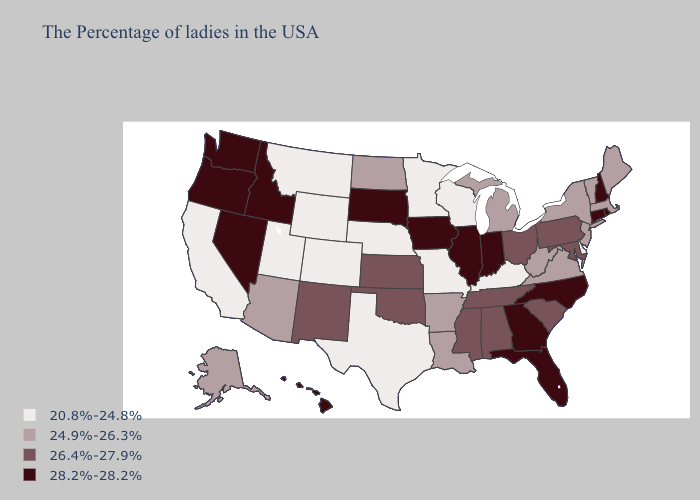What is the value of Georgia?
Write a very short answer. 28.2%-28.2%. What is the lowest value in states that border Alabama?
Keep it brief. 26.4%-27.9%. What is the highest value in states that border Maine?
Quick response, please. 28.2%-28.2%. Among the states that border South Dakota , does Minnesota have the lowest value?
Be succinct. Yes. What is the lowest value in the USA?
Answer briefly. 20.8%-24.8%. Does Nevada have the highest value in the USA?
Quick response, please. Yes. What is the value of North Carolina?
Short answer required. 28.2%-28.2%. Does Maine have the lowest value in the Northeast?
Write a very short answer. Yes. Name the states that have a value in the range 20.8%-24.8%?
Answer briefly. Delaware, Kentucky, Wisconsin, Missouri, Minnesota, Nebraska, Texas, Wyoming, Colorado, Utah, Montana, California. Does the map have missing data?
Be succinct. No. Does Missouri have a higher value than North Carolina?
Concise answer only. No. Which states hav the highest value in the West?
Concise answer only. Idaho, Nevada, Washington, Oregon, Hawaii. What is the value of New Mexico?
Give a very brief answer. 26.4%-27.9%. Does Wisconsin have a lower value than New Mexico?
Keep it brief. Yes. Among the states that border South Carolina , which have the lowest value?
Answer briefly. North Carolina, Georgia. 